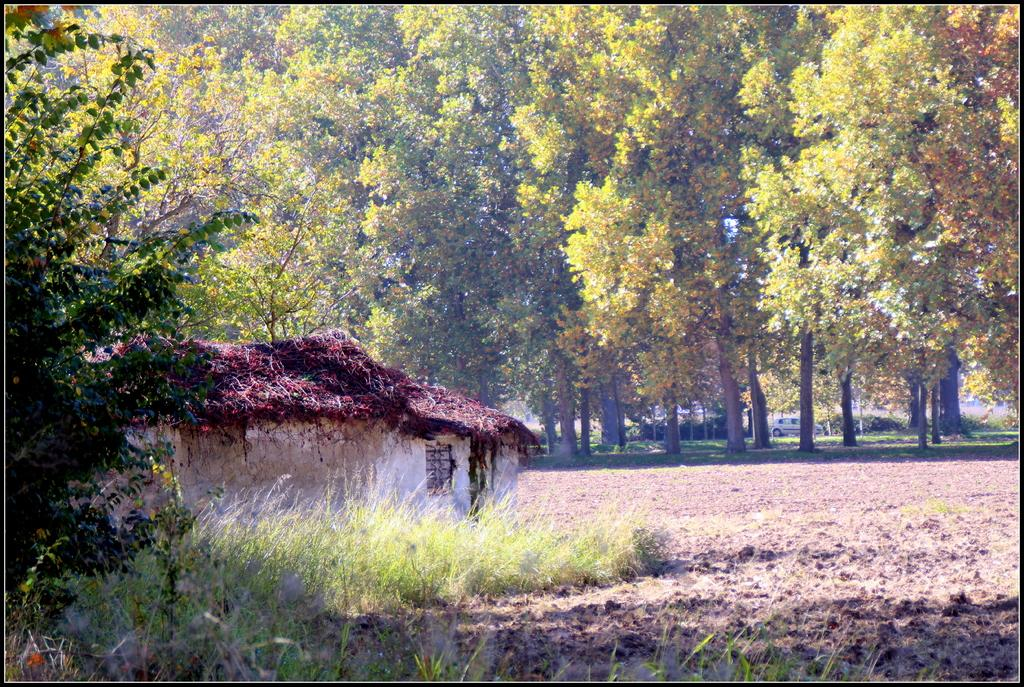What structure is located on the left side of the image? There is a house on the left side of the image. What type of vegetation is present at the bottom of the image? Grass is present on the surface at the bottom of the image. What can be seen in the background of the image? There are trees and a car in the background of the image. What type of sign is present in the image? There is no sign present in the image. How does the pollution affect the grass in the image? There is no mention of pollution in the image, and the grass appears to be unaffected. 